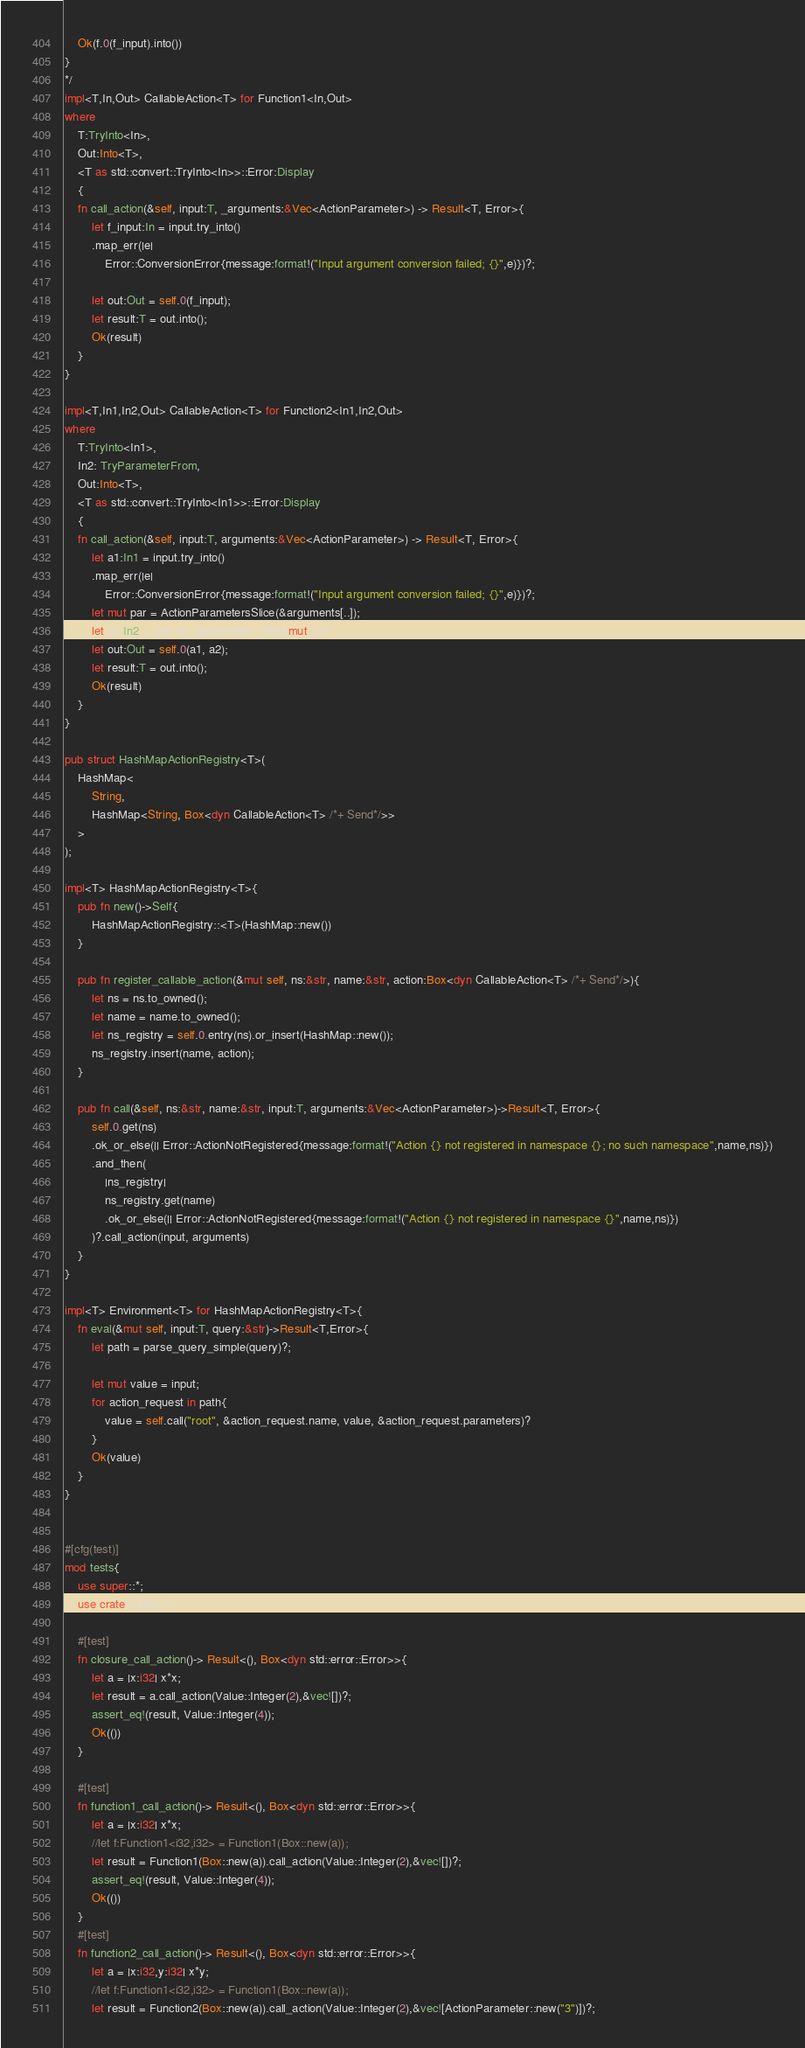<code> <loc_0><loc_0><loc_500><loc_500><_Rust_>    Ok(f.0(f_input).into())
}
*/
impl<T,In,Out> CallableAction<T> for Function1<In,Out>
where
    T:TryInto<In>,
    Out:Into<T>,
    <T as std::convert::TryInto<In>>::Error:Display
    {
    fn call_action(&self, input:T, _arguments:&Vec<ActionParameter>) -> Result<T, Error>{
        let f_input:In = input.try_into()
        .map_err(|e|
            Error::ConversionError{message:format!("Input argument conversion failed; {}",e)})?;

        let out:Out = self.0(f_input);
        let result:T = out.into();
        Ok(result)
    }
}

impl<T,In1,In2,Out> CallableAction<T> for Function2<In1,In2,Out>
where
    T:TryInto<In1>,
    In2: TryParameterFrom,
    Out:Into<T>,
    <T as std::convert::TryInto<In1>>::Error:Display
    {
    fn call_action(&self, input:T, arguments:&Vec<ActionParameter>) -> Result<T, Error>{
        let a1:In1 = input.try_into()
        .map_err(|e|
            Error::ConversionError{message:format!("Input argument conversion failed; {}",e)})?;
        let mut par = ActionParametersSlice(&arguments[..]);
        let a2:In2 =  par.try_parameters_into(&mut ())?;
        let out:Out = self.0(a1, a2);
        let result:T = out.into();
        Ok(result)
    }
}

pub struct HashMapActionRegistry<T>(
    HashMap<
        String,
        HashMap<String, Box<dyn CallableAction<T> /*+ Send*/>>  
    >
);

impl<T> HashMapActionRegistry<T>{
    pub fn new()->Self{
        HashMapActionRegistry::<T>(HashMap::new())
    }

    pub fn register_callable_action(&mut self, ns:&str, name:&str, action:Box<dyn CallableAction<T> /*+ Send*/>){
        let ns = ns.to_owned();
        let name = name.to_owned();
        let ns_registry = self.0.entry(ns).or_insert(HashMap::new());
        ns_registry.insert(name, action);
    }

    pub fn call(&self, ns:&str, name:&str, input:T, arguments:&Vec<ActionParameter>)->Result<T, Error>{
        self.0.get(ns)
        .ok_or_else(|| Error::ActionNotRegistered{message:format!("Action {} not registered in namespace {}; no such namespace",name,ns)})
        .and_then(
            |ns_registry|
            ns_registry.get(name)
            .ok_or_else(|| Error::ActionNotRegistered{message:format!("Action {} not registered in namespace {}",name,ns)})
        )?.call_action(input, arguments)
    }
}

impl<T> Environment<T> for HashMapActionRegistry<T>{
    fn eval(&mut self, input:T, query:&str)->Result<T,Error>{
        let path = parse_query_simple(query)?;

        let mut value = input;
        for action_request in path{
            value = self.call("root", &action_request.name, value, &action_request.parameters)?
        }
        Ok(value)
    }
}


#[cfg(test)]
mod tests{
    use super::*;
    use crate::value::*;

    #[test]
    fn closure_call_action()-> Result<(), Box<dyn std::error::Error>>{
        let a = |x:i32| x*x;
        let result = a.call_action(Value::Integer(2),&vec![])?;
        assert_eq!(result, Value::Integer(4));
        Ok(())
    }

    #[test]
    fn function1_call_action()-> Result<(), Box<dyn std::error::Error>>{
        let a = |x:i32| x*x;
        //let f:Function1<i32,i32> = Function1(Box::new(a));
        let result = Function1(Box::new(a)).call_action(Value::Integer(2),&vec![])?;
        assert_eq!(result, Value::Integer(4));
        Ok(())
    }
    #[test]
    fn function2_call_action()-> Result<(), Box<dyn std::error::Error>>{
        let a = |x:i32,y:i32| x*y;
        //let f:Function1<i32,i32> = Function1(Box::new(a));
        let result = Function2(Box::new(a)).call_action(Value::Integer(2),&vec![ActionParameter::new("3")])?;</code> 